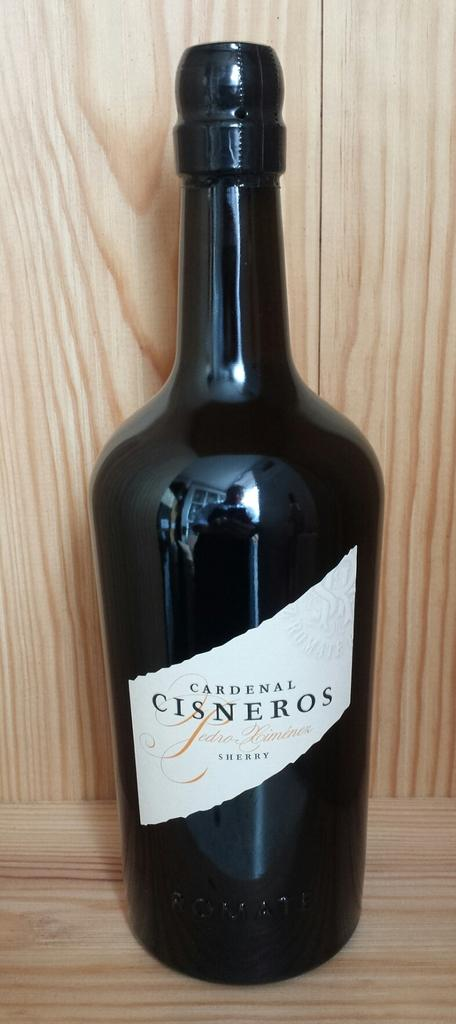Provide a one-sentence caption for the provided image. bottle of cardenal cisneros sherry on a wood shelf. 